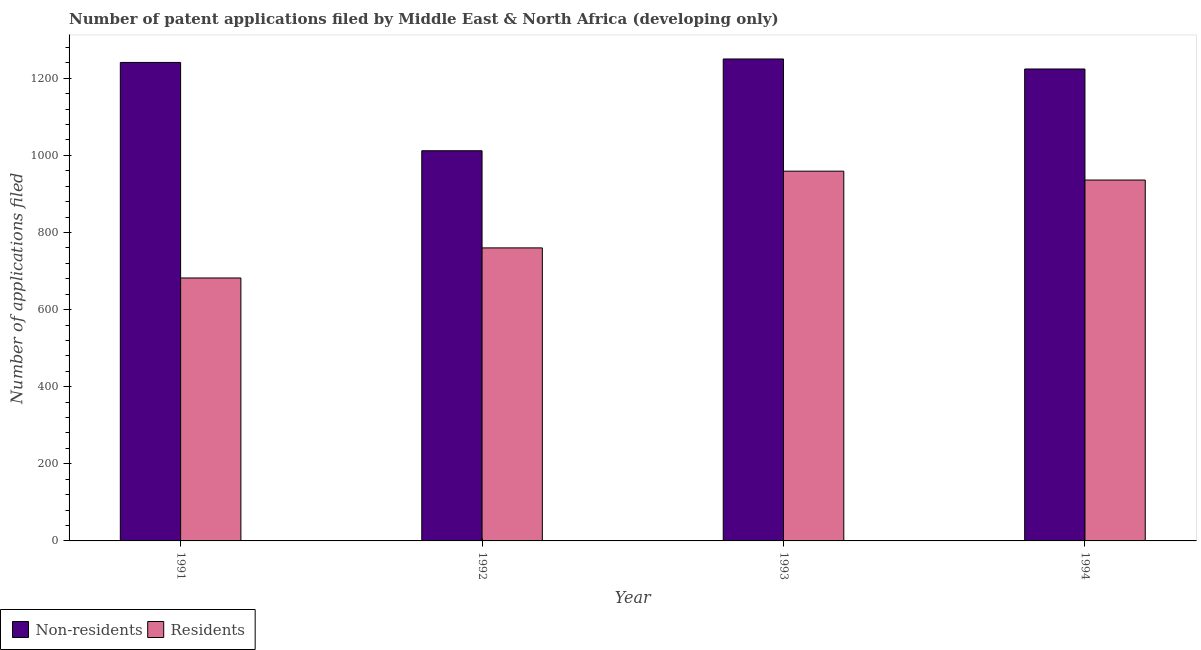How many different coloured bars are there?
Your answer should be very brief. 2. Are the number of bars on each tick of the X-axis equal?
Ensure brevity in your answer.  Yes. How many bars are there on the 3rd tick from the left?
Provide a succinct answer. 2. How many bars are there on the 1st tick from the right?
Give a very brief answer. 2. In how many cases, is the number of bars for a given year not equal to the number of legend labels?
Your response must be concise. 0. What is the number of patent applications by non residents in 1993?
Make the answer very short. 1250. Across all years, what is the maximum number of patent applications by residents?
Keep it short and to the point. 959. Across all years, what is the minimum number of patent applications by non residents?
Your answer should be very brief. 1012. In which year was the number of patent applications by non residents minimum?
Your answer should be very brief. 1992. What is the total number of patent applications by non residents in the graph?
Your response must be concise. 4727. What is the difference between the number of patent applications by non residents in 1992 and that in 1994?
Provide a succinct answer. -212. What is the difference between the number of patent applications by residents in 1992 and the number of patent applications by non residents in 1994?
Offer a terse response. -176. What is the average number of patent applications by residents per year?
Your response must be concise. 834.25. In the year 1992, what is the difference between the number of patent applications by non residents and number of patent applications by residents?
Your answer should be very brief. 0. In how many years, is the number of patent applications by residents greater than 40?
Give a very brief answer. 4. What is the ratio of the number of patent applications by non residents in 1993 to that in 1994?
Make the answer very short. 1.02. Is the number of patent applications by residents in 1991 less than that in 1993?
Offer a terse response. Yes. What is the difference between the highest and the second highest number of patent applications by non residents?
Offer a very short reply. 9. What is the difference between the highest and the lowest number of patent applications by residents?
Your response must be concise. 277. Is the sum of the number of patent applications by non residents in 1991 and 1992 greater than the maximum number of patent applications by residents across all years?
Offer a terse response. Yes. What does the 2nd bar from the left in 1992 represents?
Offer a very short reply. Residents. What does the 1st bar from the right in 1994 represents?
Give a very brief answer. Residents. How many years are there in the graph?
Give a very brief answer. 4. Are the values on the major ticks of Y-axis written in scientific E-notation?
Offer a very short reply. No. Does the graph contain grids?
Your answer should be very brief. No. How are the legend labels stacked?
Your response must be concise. Horizontal. What is the title of the graph?
Keep it short and to the point. Number of patent applications filed by Middle East & North Africa (developing only). Does "Number of departures" appear as one of the legend labels in the graph?
Keep it short and to the point. No. What is the label or title of the X-axis?
Ensure brevity in your answer.  Year. What is the label or title of the Y-axis?
Provide a succinct answer. Number of applications filed. What is the Number of applications filed of Non-residents in 1991?
Your answer should be compact. 1241. What is the Number of applications filed in Residents in 1991?
Ensure brevity in your answer.  682. What is the Number of applications filed in Non-residents in 1992?
Give a very brief answer. 1012. What is the Number of applications filed of Residents in 1992?
Keep it short and to the point. 760. What is the Number of applications filed of Non-residents in 1993?
Provide a short and direct response. 1250. What is the Number of applications filed in Residents in 1993?
Keep it short and to the point. 959. What is the Number of applications filed in Non-residents in 1994?
Ensure brevity in your answer.  1224. What is the Number of applications filed in Residents in 1994?
Provide a succinct answer. 936. Across all years, what is the maximum Number of applications filed of Non-residents?
Keep it short and to the point. 1250. Across all years, what is the maximum Number of applications filed of Residents?
Keep it short and to the point. 959. Across all years, what is the minimum Number of applications filed in Non-residents?
Ensure brevity in your answer.  1012. Across all years, what is the minimum Number of applications filed in Residents?
Keep it short and to the point. 682. What is the total Number of applications filed in Non-residents in the graph?
Keep it short and to the point. 4727. What is the total Number of applications filed of Residents in the graph?
Keep it short and to the point. 3337. What is the difference between the Number of applications filed in Non-residents in 1991 and that in 1992?
Offer a terse response. 229. What is the difference between the Number of applications filed in Residents in 1991 and that in 1992?
Your response must be concise. -78. What is the difference between the Number of applications filed of Non-residents in 1991 and that in 1993?
Your answer should be very brief. -9. What is the difference between the Number of applications filed in Residents in 1991 and that in 1993?
Offer a very short reply. -277. What is the difference between the Number of applications filed in Residents in 1991 and that in 1994?
Provide a succinct answer. -254. What is the difference between the Number of applications filed of Non-residents in 1992 and that in 1993?
Ensure brevity in your answer.  -238. What is the difference between the Number of applications filed in Residents in 1992 and that in 1993?
Ensure brevity in your answer.  -199. What is the difference between the Number of applications filed in Non-residents in 1992 and that in 1994?
Your response must be concise. -212. What is the difference between the Number of applications filed of Residents in 1992 and that in 1994?
Provide a succinct answer. -176. What is the difference between the Number of applications filed of Non-residents in 1993 and that in 1994?
Your answer should be very brief. 26. What is the difference between the Number of applications filed of Non-residents in 1991 and the Number of applications filed of Residents in 1992?
Ensure brevity in your answer.  481. What is the difference between the Number of applications filed of Non-residents in 1991 and the Number of applications filed of Residents in 1993?
Make the answer very short. 282. What is the difference between the Number of applications filed of Non-residents in 1991 and the Number of applications filed of Residents in 1994?
Offer a very short reply. 305. What is the difference between the Number of applications filed in Non-residents in 1993 and the Number of applications filed in Residents in 1994?
Offer a very short reply. 314. What is the average Number of applications filed of Non-residents per year?
Provide a short and direct response. 1181.75. What is the average Number of applications filed in Residents per year?
Provide a succinct answer. 834.25. In the year 1991, what is the difference between the Number of applications filed in Non-residents and Number of applications filed in Residents?
Your answer should be compact. 559. In the year 1992, what is the difference between the Number of applications filed in Non-residents and Number of applications filed in Residents?
Keep it short and to the point. 252. In the year 1993, what is the difference between the Number of applications filed in Non-residents and Number of applications filed in Residents?
Offer a terse response. 291. In the year 1994, what is the difference between the Number of applications filed in Non-residents and Number of applications filed in Residents?
Your answer should be very brief. 288. What is the ratio of the Number of applications filed in Non-residents in 1991 to that in 1992?
Give a very brief answer. 1.23. What is the ratio of the Number of applications filed in Residents in 1991 to that in 1992?
Give a very brief answer. 0.9. What is the ratio of the Number of applications filed in Non-residents in 1991 to that in 1993?
Provide a succinct answer. 0.99. What is the ratio of the Number of applications filed of Residents in 1991 to that in 1993?
Your answer should be very brief. 0.71. What is the ratio of the Number of applications filed of Non-residents in 1991 to that in 1994?
Offer a very short reply. 1.01. What is the ratio of the Number of applications filed in Residents in 1991 to that in 1994?
Make the answer very short. 0.73. What is the ratio of the Number of applications filed in Non-residents in 1992 to that in 1993?
Make the answer very short. 0.81. What is the ratio of the Number of applications filed in Residents in 1992 to that in 1993?
Keep it short and to the point. 0.79. What is the ratio of the Number of applications filed of Non-residents in 1992 to that in 1994?
Keep it short and to the point. 0.83. What is the ratio of the Number of applications filed of Residents in 1992 to that in 1994?
Your answer should be compact. 0.81. What is the ratio of the Number of applications filed of Non-residents in 1993 to that in 1994?
Offer a terse response. 1.02. What is the ratio of the Number of applications filed of Residents in 1993 to that in 1994?
Ensure brevity in your answer.  1.02. What is the difference between the highest and the second highest Number of applications filed of Non-residents?
Your answer should be very brief. 9. What is the difference between the highest and the lowest Number of applications filed of Non-residents?
Offer a terse response. 238. What is the difference between the highest and the lowest Number of applications filed in Residents?
Your answer should be very brief. 277. 